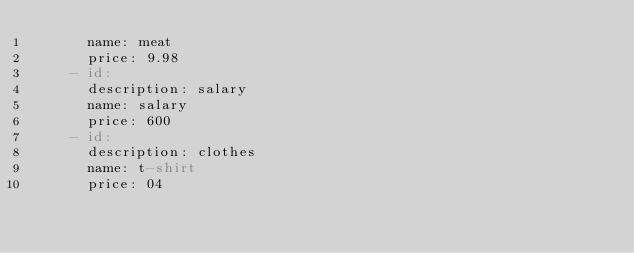Convert code to text. <code><loc_0><loc_0><loc_500><loc_500><_YAML_>      name: meat
      price: 9.98
    - id:
      description: salary
      name: salary
      price: 600
    - id:
      description: clothes
      name: t-shirt
      price: 04
</code> 